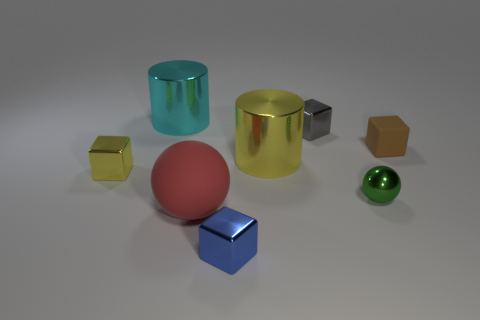There is a small gray object that is made of the same material as the big yellow cylinder; what is its shape?
Give a very brief answer. Cube. What is the material of the large red object that is the same shape as the tiny green shiny object?
Offer a very short reply. Rubber. How many small yellow objects are the same shape as the tiny blue shiny thing?
Offer a very short reply. 1. Do the cyan metallic thing that is left of the small brown matte cube and the yellow object that is in front of the yellow cylinder have the same size?
Give a very brief answer. No. What shape is the large object that is behind the cylinder right of the cyan object?
Provide a succinct answer. Cylinder. Are there the same number of shiny objects on the left side of the large yellow metal thing and tiny gray metal objects?
Your answer should be very brief. No. There is a cylinder that is on the right side of the red matte object that is behind the small block that is in front of the yellow shiny cube; what is its material?
Make the answer very short. Metal. Is there a cyan thing that has the same size as the red object?
Make the answer very short. Yes. The green thing has what shape?
Your response must be concise. Sphere. What number of spheres are either cyan metallic things or yellow things?
Offer a terse response. 0. 